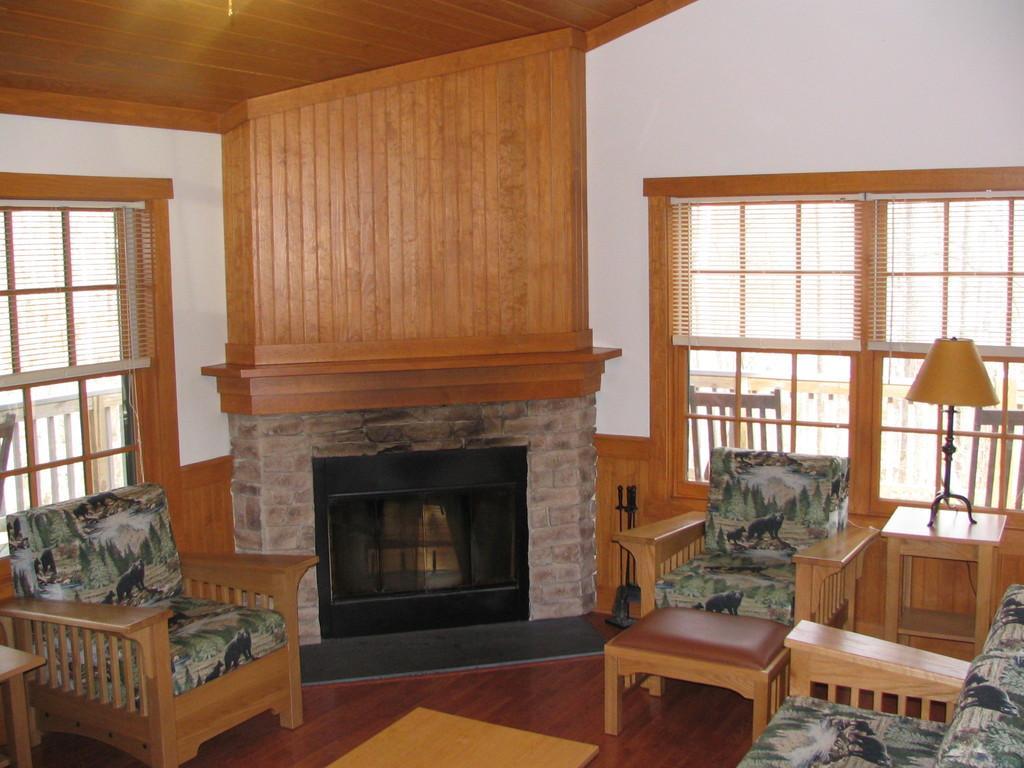How would you summarize this image in a sentence or two? This is an inside view of a room. Here I can see a couch, table, chairs are placed on the floor and also there is a fireplace. On the right and left side of the image there are two windows to the wall. 